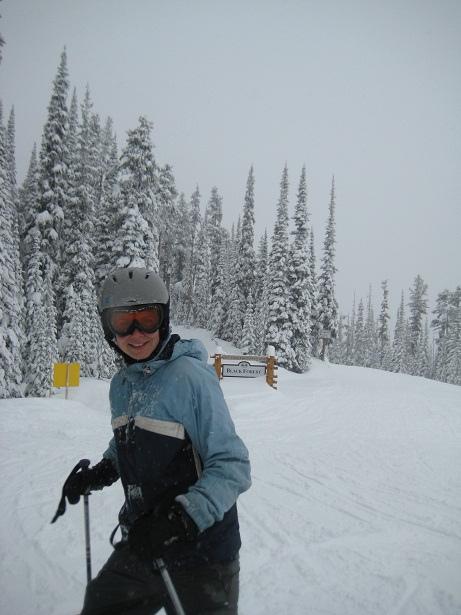Is the person in this photo male or female?
Write a very short answer. Male. Where is the yellow sign?
Be succinct. Treeline. Are all the trees covered in snow?
Answer briefly. Yes. 